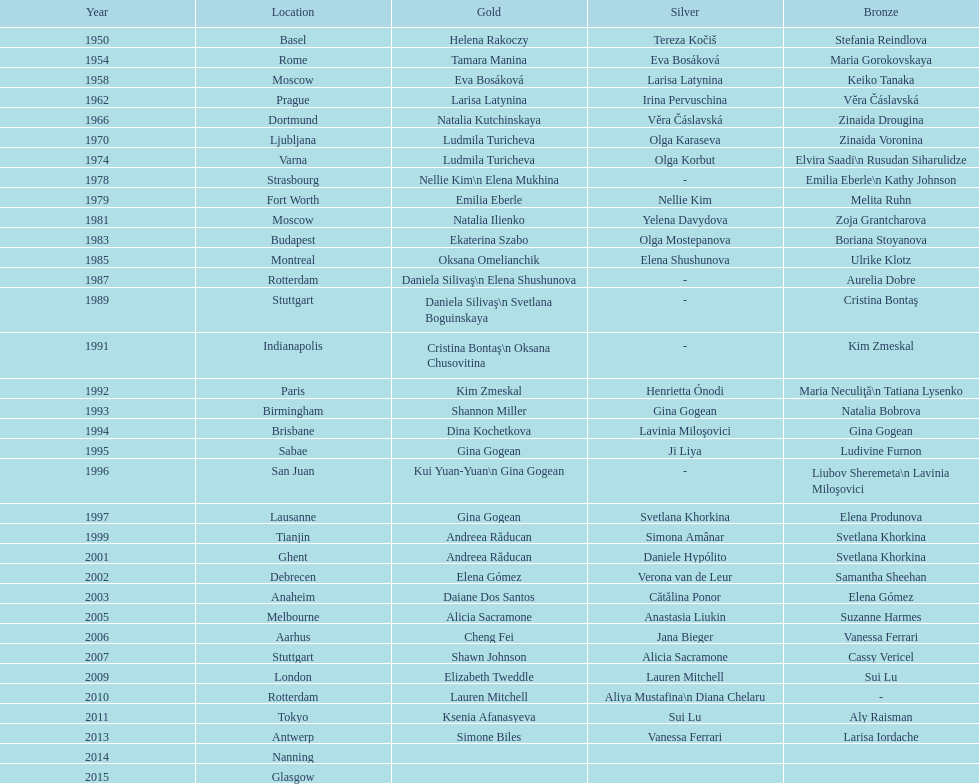How long is the time between the times the championship was held in moscow? 23 years. 